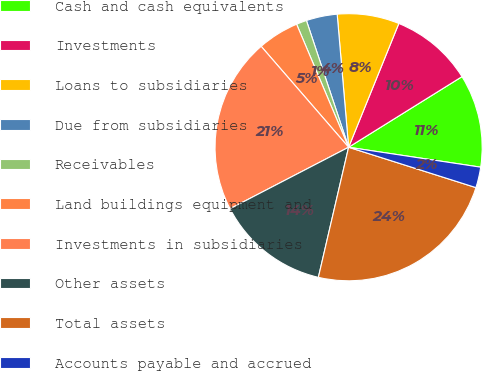Convert chart. <chart><loc_0><loc_0><loc_500><loc_500><pie_chart><fcel>Cash and cash equivalents<fcel>Investments<fcel>Loans to subsidiaries<fcel>Due from subsidiaries<fcel>Receivables<fcel>Land buildings equipment and<fcel>Investments in subsidiaries<fcel>Other assets<fcel>Total assets<fcel>Accounts payable and accrued<nl><fcel>11.25%<fcel>10.0%<fcel>7.5%<fcel>3.75%<fcel>1.25%<fcel>5.0%<fcel>21.25%<fcel>13.75%<fcel>23.75%<fcel>2.5%<nl></chart> 